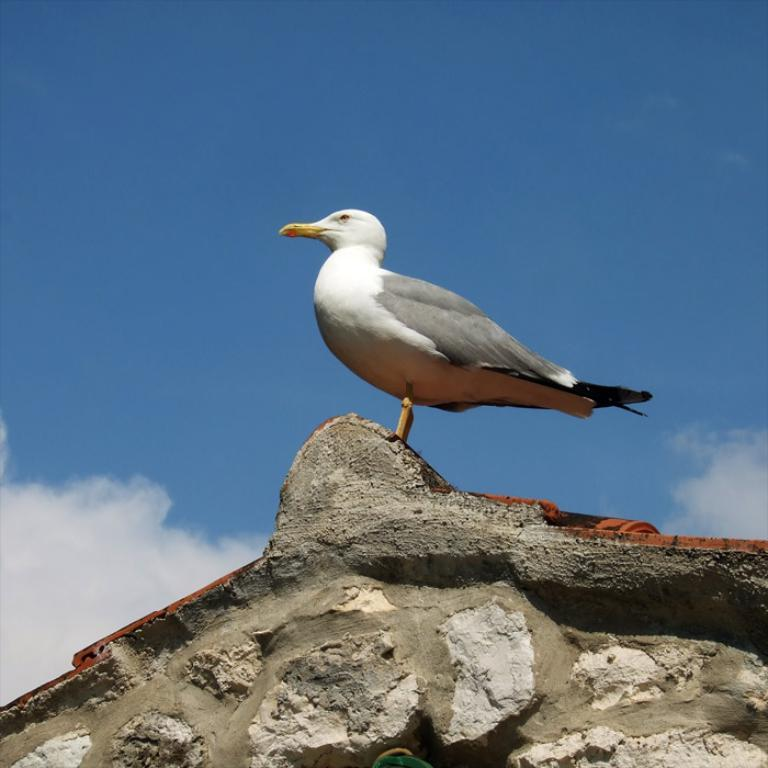What type of animal can be seen in the image? There is a bird in the image. Where is the bird located in the image? The bird is on an object in the image. What can be seen in the background of the image? The sky is visible in the image, and clouds are present in the sky. What type of body of water is visible in the image? There is no body of water present in the image; it features a bird on an object with a sky background and clouds. 